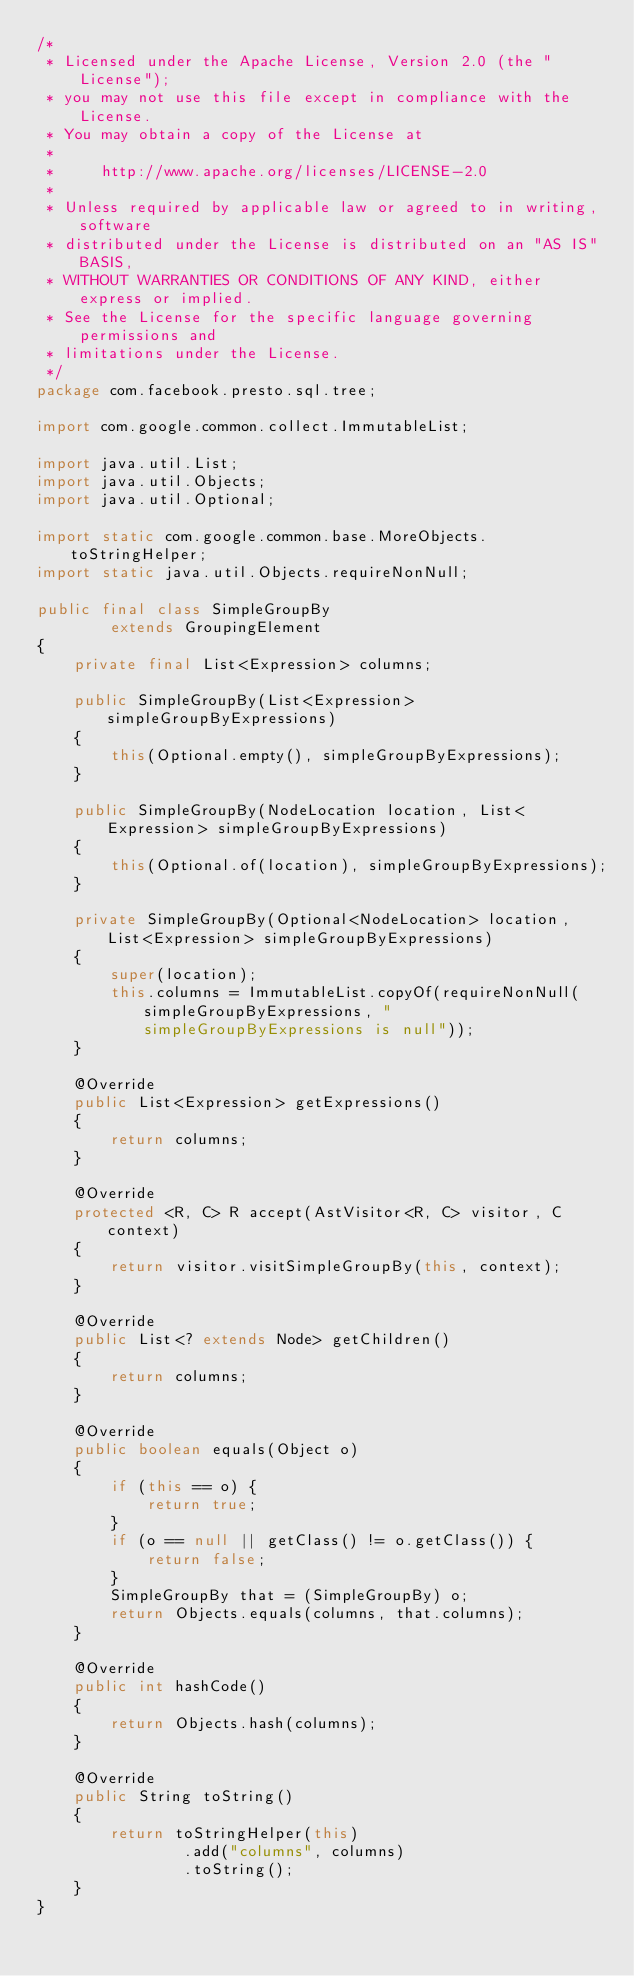<code> <loc_0><loc_0><loc_500><loc_500><_Java_>/*
 * Licensed under the Apache License, Version 2.0 (the "License");
 * you may not use this file except in compliance with the License.
 * You may obtain a copy of the License at
 *
 *     http://www.apache.org/licenses/LICENSE-2.0
 *
 * Unless required by applicable law or agreed to in writing, software
 * distributed under the License is distributed on an "AS IS" BASIS,
 * WITHOUT WARRANTIES OR CONDITIONS OF ANY KIND, either express or implied.
 * See the License for the specific language governing permissions and
 * limitations under the License.
 */
package com.facebook.presto.sql.tree;

import com.google.common.collect.ImmutableList;

import java.util.List;
import java.util.Objects;
import java.util.Optional;

import static com.google.common.base.MoreObjects.toStringHelper;
import static java.util.Objects.requireNonNull;

public final class SimpleGroupBy
        extends GroupingElement
{
    private final List<Expression> columns;

    public SimpleGroupBy(List<Expression> simpleGroupByExpressions)
    {
        this(Optional.empty(), simpleGroupByExpressions);
    }

    public SimpleGroupBy(NodeLocation location, List<Expression> simpleGroupByExpressions)
    {
        this(Optional.of(location), simpleGroupByExpressions);
    }

    private SimpleGroupBy(Optional<NodeLocation> location, List<Expression> simpleGroupByExpressions)
    {
        super(location);
        this.columns = ImmutableList.copyOf(requireNonNull(simpleGroupByExpressions, "simpleGroupByExpressions is null"));
    }

    @Override
    public List<Expression> getExpressions()
    {
        return columns;
    }

    @Override
    protected <R, C> R accept(AstVisitor<R, C> visitor, C context)
    {
        return visitor.visitSimpleGroupBy(this, context);
    }

    @Override
    public List<? extends Node> getChildren()
    {
        return columns;
    }

    @Override
    public boolean equals(Object o)
    {
        if (this == o) {
            return true;
        }
        if (o == null || getClass() != o.getClass()) {
            return false;
        }
        SimpleGroupBy that = (SimpleGroupBy) o;
        return Objects.equals(columns, that.columns);
    }

    @Override
    public int hashCode()
    {
        return Objects.hash(columns);
    }

    @Override
    public String toString()
    {
        return toStringHelper(this)
                .add("columns", columns)
                .toString();
    }
}
</code> 